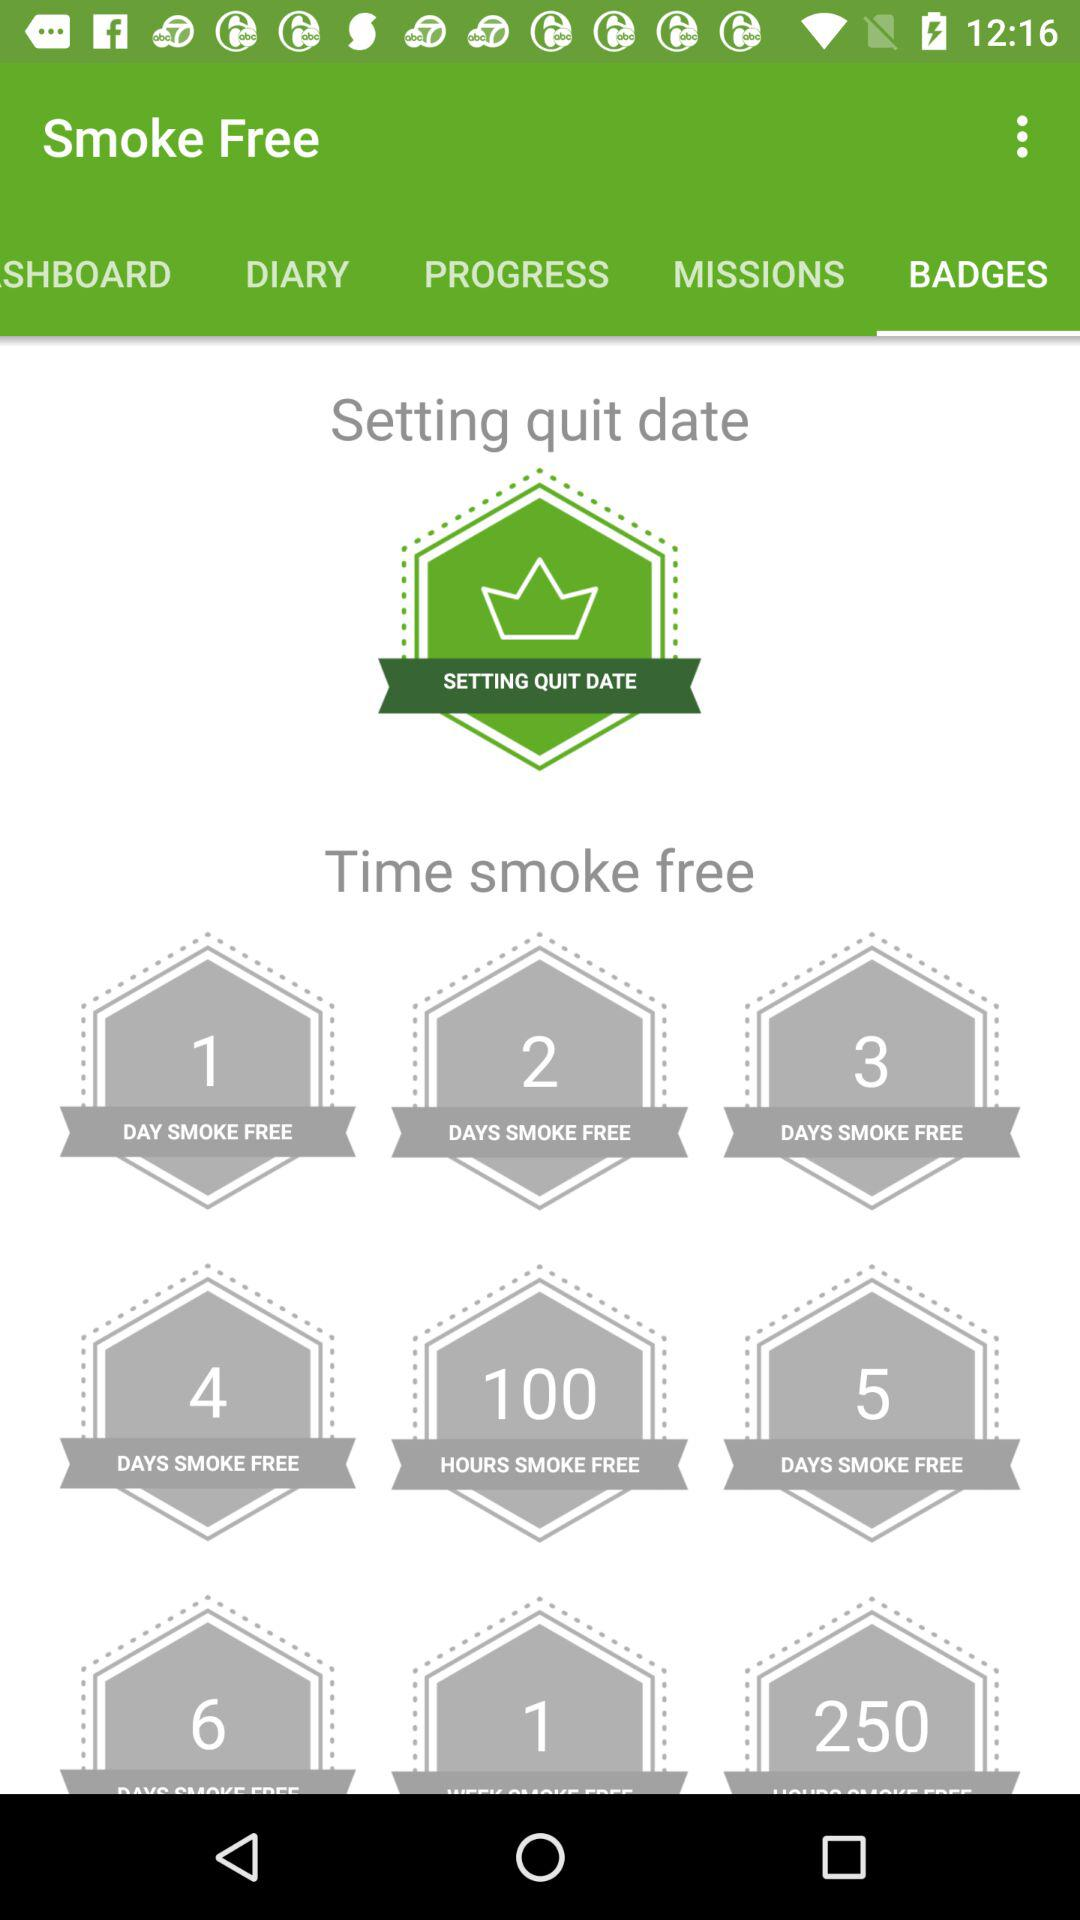Which tab is selected? The selected tab is "BADGES". 